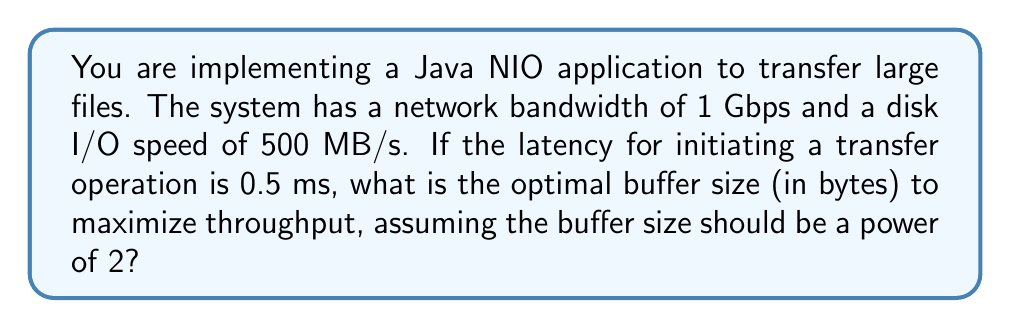Show me your answer to this math problem. To determine the optimal buffer size, we need to balance the time spent on data transfer and the overhead of initiating transfer operations. Let's approach this step-by-step:

1. Convert units to consistent measures:
   Network bandwidth: 1 Gbps = $10^9$ bits/s = $1.25 \times 10^8$ bytes/s
   Disk I/O speed: 500 MB/s = $5 \times 10^8$ bytes/s
   Latency: 0.5 ms = $5 \times 10^{-4}$ s

2. The bottleneck in data transfer will be the slower of network or disk I/O:
   $\text{Transfer rate} = \min(1.25 \times 10^8, 5 \times 10^8) = 1.25 \times 10^8$ bytes/s

3. Let $x$ be the buffer size in bytes. The time to transfer a buffer is:
   $T_{\text{transfer}} = \frac{x}{1.25 \times 10^8}$ s

4. The total time for one buffer operation is:
   $T_{\text{total}} = T_{\text{transfer}} + T_{\text{latency}} = \frac{x}{1.25 \times 10^8} + 5 \times 10^{-4}$ s

5. The throughput is:
   $\text{Throughput} = \frac{x}{T_{\text{total}}} = \frac{x}{\frac{x}{1.25 \times 10^8} + 5 \times 10^{-4}}$ bytes/s

6. To maximize throughput, we differentiate with respect to $x$ and set to zero:
   $$\frac{d}{dx}\left(\frac{x}{\frac{x}{1.25 \times 10^8} + 5 \times 10^{-4}}\right) = 0$$

7. Solving this equation yields:
   $x_{\text{optimal}} = 1.25 \times 10^8 \times 5 \times 10^{-4} = 62,500$ bytes

8. The closest power of 2 to this value is:
   $2^{16} = 65,536$ bytes

Therefore, the optimal buffer size that is a power of 2 is 65,536 bytes.
Answer: 65,536 bytes 